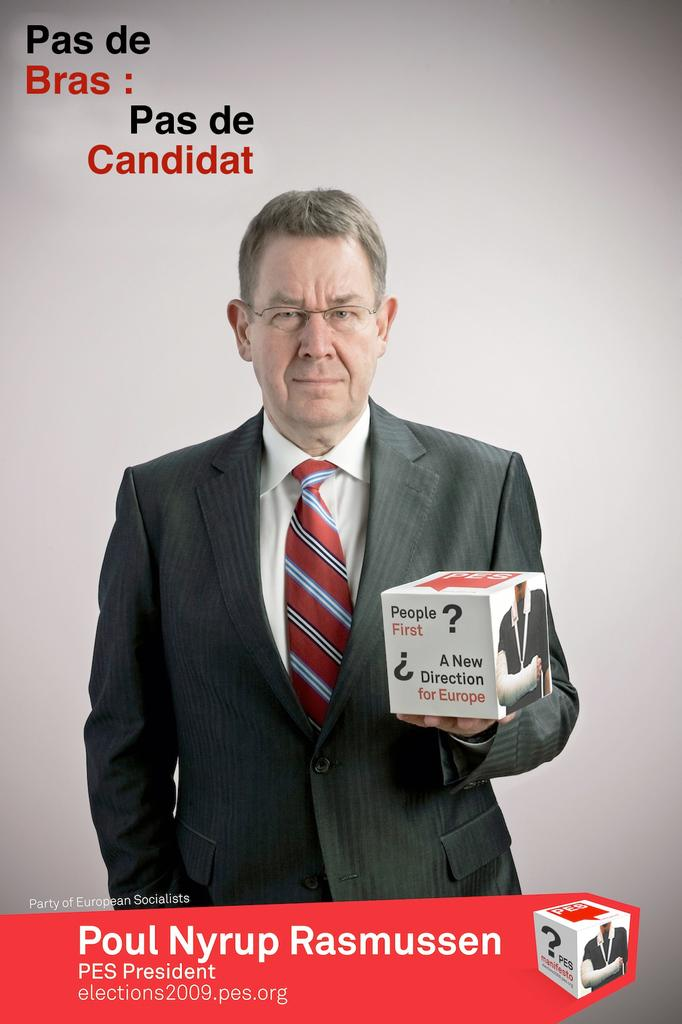Who is the main subject in the image? There is a man in the image. Where is the man positioned in the image? The man is standing in the center of the image. What is the man holding in the image? The man is holding a box. What type of sail can be seen on the man's head in the image? There is no sail present on the man's head in the image. How many ants are crawling on the man's arm in the image? There are no ants present on the man's arm in the image. 